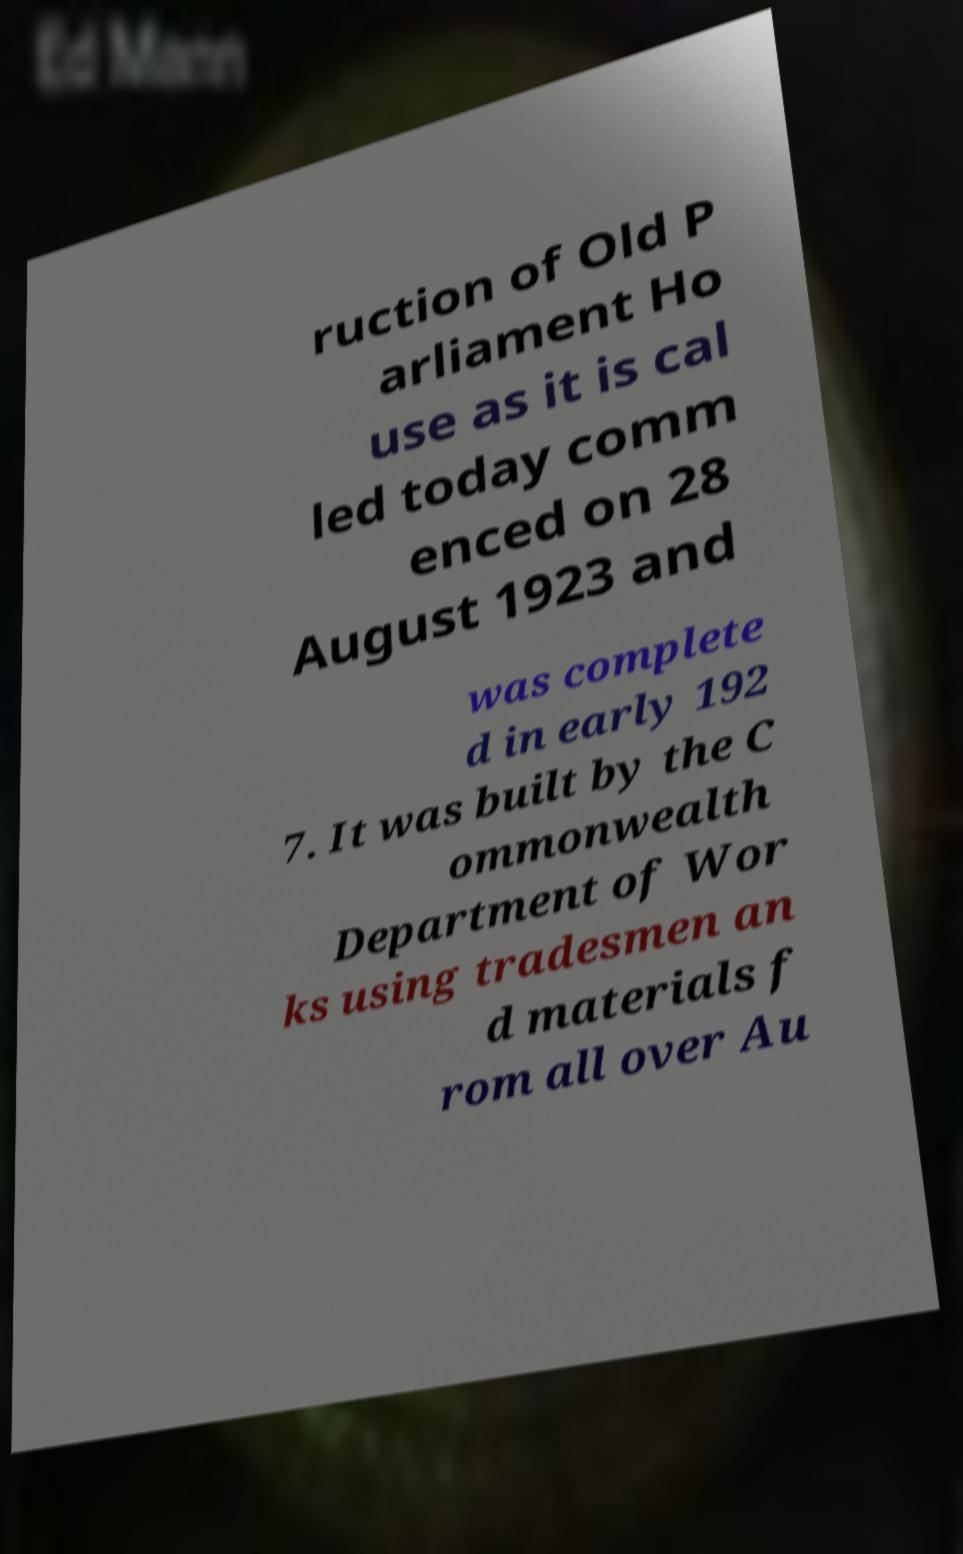Can you read and provide the text displayed in the image?This photo seems to have some interesting text. Can you extract and type it out for me? ruction of Old P arliament Ho use as it is cal led today comm enced on 28 August 1923 and was complete d in early 192 7. It was built by the C ommonwealth Department of Wor ks using tradesmen an d materials f rom all over Au 